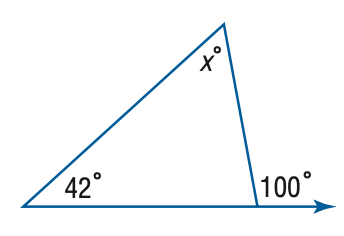Question: Find x.
Choices:
A. 42
B. 48
C. 52
D. 58
Answer with the letter. Answer: D 